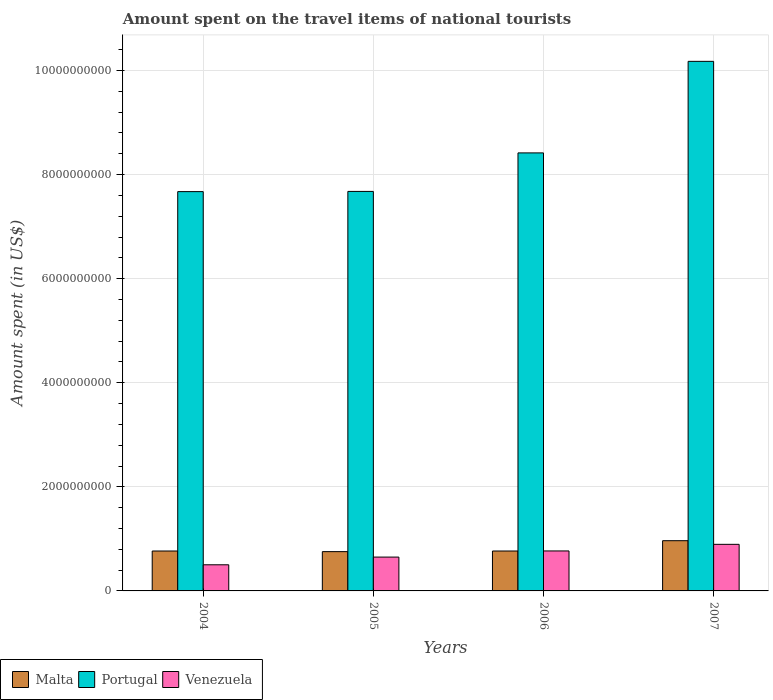How many different coloured bars are there?
Your answer should be very brief. 3. How many groups of bars are there?
Ensure brevity in your answer.  4. Are the number of bars on each tick of the X-axis equal?
Your response must be concise. Yes. How many bars are there on the 2nd tick from the left?
Ensure brevity in your answer.  3. How many bars are there on the 2nd tick from the right?
Make the answer very short. 3. What is the label of the 3rd group of bars from the left?
Ensure brevity in your answer.  2006. In how many cases, is the number of bars for a given year not equal to the number of legend labels?
Your response must be concise. 0. What is the amount spent on the travel items of national tourists in Malta in 2004?
Give a very brief answer. 7.67e+08. Across all years, what is the maximum amount spent on the travel items of national tourists in Venezuela?
Offer a terse response. 8.95e+08. Across all years, what is the minimum amount spent on the travel items of national tourists in Malta?
Provide a succinct answer. 7.55e+08. What is the total amount spent on the travel items of national tourists in Venezuela in the graph?
Your answer should be very brief. 2.82e+09. What is the difference between the amount spent on the travel items of national tourists in Portugal in 2005 and that in 2007?
Provide a short and direct response. -2.50e+09. What is the difference between the amount spent on the travel items of national tourists in Portugal in 2006 and the amount spent on the travel items of national tourists in Venezuela in 2004?
Offer a very short reply. 7.91e+09. What is the average amount spent on the travel items of national tourists in Malta per year?
Provide a succinct answer. 8.14e+08. In the year 2007, what is the difference between the amount spent on the travel items of national tourists in Portugal and amount spent on the travel items of national tourists in Malta?
Offer a terse response. 9.21e+09. In how many years, is the amount spent on the travel items of national tourists in Portugal greater than 7200000000 US$?
Offer a terse response. 4. What is the ratio of the amount spent on the travel items of national tourists in Malta in 2006 to that in 2007?
Offer a very short reply. 0.79. Is the amount spent on the travel items of national tourists in Malta in 2006 less than that in 2007?
Provide a short and direct response. Yes. What is the difference between the highest and the second highest amount spent on the travel items of national tourists in Venezuela?
Your response must be concise. 1.27e+08. What is the difference between the highest and the lowest amount spent on the travel items of national tourists in Portugal?
Provide a short and direct response. 2.50e+09. Is the sum of the amount spent on the travel items of national tourists in Portugal in 2004 and 2007 greater than the maximum amount spent on the travel items of national tourists in Venezuela across all years?
Ensure brevity in your answer.  Yes. What does the 1st bar from the left in 2004 represents?
Provide a short and direct response. Malta. How many years are there in the graph?
Give a very brief answer. 4. Does the graph contain grids?
Offer a terse response. Yes. Where does the legend appear in the graph?
Your answer should be very brief. Bottom left. How are the legend labels stacked?
Your answer should be compact. Horizontal. What is the title of the graph?
Provide a short and direct response. Amount spent on the travel items of national tourists. What is the label or title of the X-axis?
Offer a terse response. Years. What is the label or title of the Y-axis?
Ensure brevity in your answer.  Amount spent (in US$). What is the Amount spent (in US$) in Malta in 2004?
Provide a succinct answer. 7.67e+08. What is the Amount spent (in US$) in Portugal in 2004?
Offer a very short reply. 7.67e+09. What is the Amount spent (in US$) in Venezuela in 2004?
Provide a succinct answer. 5.02e+08. What is the Amount spent (in US$) in Malta in 2005?
Your answer should be very brief. 7.55e+08. What is the Amount spent (in US$) in Portugal in 2005?
Give a very brief answer. 7.68e+09. What is the Amount spent (in US$) in Venezuela in 2005?
Offer a very short reply. 6.50e+08. What is the Amount spent (in US$) in Malta in 2006?
Provide a succinct answer. 7.67e+08. What is the Amount spent (in US$) of Portugal in 2006?
Make the answer very short. 8.42e+09. What is the Amount spent (in US$) in Venezuela in 2006?
Your response must be concise. 7.68e+08. What is the Amount spent (in US$) in Malta in 2007?
Your answer should be compact. 9.65e+08. What is the Amount spent (in US$) in Portugal in 2007?
Your response must be concise. 1.02e+1. What is the Amount spent (in US$) in Venezuela in 2007?
Your response must be concise. 8.95e+08. Across all years, what is the maximum Amount spent (in US$) of Malta?
Provide a short and direct response. 9.65e+08. Across all years, what is the maximum Amount spent (in US$) of Portugal?
Make the answer very short. 1.02e+1. Across all years, what is the maximum Amount spent (in US$) of Venezuela?
Offer a very short reply. 8.95e+08. Across all years, what is the minimum Amount spent (in US$) of Malta?
Make the answer very short. 7.55e+08. Across all years, what is the minimum Amount spent (in US$) in Portugal?
Ensure brevity in your answer.  7.67e+09. Across all years, what is the minimum Amount spent (in US$) in Venezuela?
Keep it short and to the point. 5.02e+08. What is the total Amount spent (in US$) in Malta in the graph?
Your response must be concise. 3.25e+09. What is the total Amount spent (in US$) in Portugal in the graph?
Ensure brevity in your answer.  3.39e+1. What is the total Amount spent (in US$) of Venezuela in the graph?
Provide a succinct answer. 2.82e+09. What is the difference between the Amount spent (in US$) in Portugal in 2004 and that in 2005?
Your answer should be very brief. -4.00e+06. What is the difference between the Amount spent (in US$) in Venezuela in 2004 and that in 2005?
Your response must be concise. -1.48e+08. What is the difference between the Amount spent (in US$) of Malta in 2004 and that in 2006?
Your answer should be compact. 0. What is the difference between the Amount spent (in US$) of Portugal in 2004 and that in 2006?
Keep it short and to the point. -7.44e+08. What is the difference between the Amount spent (in US$) in Venezuela in 2004 and that in 2006?
Provide a short and direct response. -2.66e+08. What is the difference between the Amount spent (in US$) in Malta in 2004 and that in 2007?
Your answer should be compact. -1.98e+08. What is the difference between the Amount spent (in US$) in Portugal in 2004 and that in 2007?
Give a very brief answer. -2.50e+09. What is the difference between the Amount spent (in US$) in Venezuela in 2004 and that in 2007?
Ensure brevity in your answer.  -3.93e+08. What is the difference between the Amount spent (in US$) in Malta in 2005 and that in 2006?
Offer a very short reply. -1.20e+07. What is the difference between the Amount spent (in US$) of Portugal in 2005 and that in 2006?
Provide a succinct answer. -7.40e+08. What is the difference between the Amount spent (in US$) in Venezuela in 2005 and that in 2006?
Offer a terse response. -1.18e+08. What is the difference between the Amount spent (in US$) of Malta in 2005 and that in 2007?
Make the answer very short. -2.10e+08. What is the difference between the Amount spent (in US$) of Portugal in 2005 and that in 2007?
Provide a succinct answer. -2.50e+09. What is the difference between the Amount spent (in US$) of Venezuela in 2005 and that in 2007?
Make the answer very short. -2.45e+08. What is the difference between the Amount spent (in US$) in Malta in 2006 and that in 2007?
Provide a short and direct response. -1.98e+08. What is the difference between the Amount spent (in US$) of Portugal in 2006 and that in 2007?
Keep it short and to the point. -1.76e+09. What is the difference between the Amount spent (in US$) in Venezuela in 2006 and that in 2007?
Your answer should be very brief. -1.27e+08. What is the difference between the Amount spent (in US$) in Malta in 2004 and the Amount spent (in US$) in Portugal in 2005?
Your answer should be compact. -6.91e+09. What is the difference between the Amount spent (in US$) of Malta in 2004 and the Amount spent (in US$) of Venezuela in 2005?
Provide a succinct answer. 1.17e+08. What is the difference between the Amount spent (in US$) of Portugal in 2004 and the Amount spent (in US$) of Venezuela in 2005?
Ensure brevity in your answer.  7.02e+09. What is the difference between the Amount spent (in US$) in Malta in 2004 and the Amount spent (in US$) in Portugal in 2006?
Ensure brevity in your answer.  -7.65e+09. What is the difference between the Amount spent (in US$) of Malta in 2004 and the Amount spent (in US$) of Venezuela in 2006?
Your response must be concise. -1.00e+06. What is the difference between the Amount spent (in US$) in Portugal in 2004 and the Amount spent (in US$) in Venezuela in 2006?
Your answer should be compact. 6.90e+09. What is the difference between the Amount spent (in US$) in Malta in 2004 and the Amount spent (in US$) in Portugal in 2007?
Your answer should be very brief. -9.41e+09. What is the difference between the Amount spent (in US$) of Malta in 2004 and the Amount spent (in US$) of Venezuela in 2007?
Your answer should be compact. -1.28e+08. What is the difference between the Amount spent (in US$) in Portugal in 2004 and the Amount spent (in US$) in Venezuela in 2007?
Provide a short and direct response. 6.78e+09. What is the difference between the Amount spent (in US$) in Malta in 2005 and the Amount spent (in US$) in Portugal in 2006?
Keep it short and to the point. -7.66e+09. What is the difference between the Amount spent (in US$) in Malta in 2005 and the Amount spent (in US$) in Venezuela in 2006?
Make the answer very short. -1.30e+07. What is the difference between the Amount spent (in US$) of Portugal in 2005 and the Amount spent (in US$) of Venezuela in 2006?
Offer a very short reply. 6.91e+09. What is the difference between the Amount spent (in US$) in Malta in 2005 and the Amount spent (in US$) in Portugal in 2007?
Provide a short and direct response. -9.42e+09. What is the difference between the Amount spent (in US$) in Malta in 2005 and the Amount spent (in US$) in Venezuela in 2007?
Offer a terse response. -1.40e+08. What is the difference between the Amount spent (in US$) of Portugal in 2005 and the Amount spent (in US$) of Venezuela in 2007?
Offer a very short reply. 6.78e+09. What is the difference between the Amount spent (in US$) of Malta in 2006 and the Amount spent (in US$) of Portugal in 2007?
Provide a short and direct response. -9.41e+09. What is the difference between the Amount spent (in US$) of Malta in 2006 and the Amount spent (in US$) of Venezuela in 2007?
Make the answer very short. -1.28e+08. What is the difference between the Amount spent (in US$) of Portugal in 2006 and the Amount spent (in US$) of Venezuela in 2007?
Your answer should be compact. 7.52e+09. What is the average Amount spent (in US$) of Malta per year?
Offer a very short reply. 8.14e+08. What is the average Amount spent (in US$) in Portugal per year?
Give a very brief answer. 8.48e+09. What is the average Amount spent (in US$) of Venezuela per year?
Provide a succinct answer. 7.04e+08. In the year 2004, what is the difference between the Amount spent (in US$) in Malta and Amount spent (in US$) in Portugal?
Your answer should be very brief. -6.90e+09. In the year 2004, what is the difference between the Amount spent (in US$) in Malta and Amount spent (in US$) in Venezuela?
Provide a short and direct response. 2.65e+08. In the year 2004, what is the difference between the Amount spent (in US$) in Portugal and Amount spent (in US$) in Venezuela?
Offer a very short reply. 7.17e+09. In the year 2005, what is the difference between the Amount spent (in US$) in Malta and Amount spent (in US$) in Portugal?
Your answer should be compact. -6.92e+09. In the year 2005, what is the difference between the Amount spent (in US$) of Malta and Amount spent (in US$) of Venezuela?
Offer a terse response. 1.05e+08. In the year 2005, what is the difference between the Amount spent (in US$) in Portugal and Amount spent (in US$) in Venezuela?
Give a very brief answer. 7.03e+09. In the year 2006, what is the difference between the Amount spent (in US$) in Malta and Amount spent (in US$) in Portugal?
Your response must be concise. -7.65e+09. In the year 2006, what is the difference between the Amount spent (in US$) of Portugal and Amount spent (in US$) of Venezuela?
Keep it short and to the point. 7.65e+09. In the year 2007, what is the difference between the Amount spent (in US$) of Malta and Amount spent (in US$) of Portugal?
Ensure brevity in your answer.  -9.21e+09. In the year 2007, what is the difference between the Amount spent (in US$) in Malta and Amount spent (in US$) in Venezuela?
Offer a terse response. 7.00e+07. In the year 2007, what is the difference between the Amount spent (in US$) in Portugal and Amount spent (in US$) in Venezuela?
Keep it short and to the point. 9.28e+09. What is the ratio of the Amount spent (in US$) in Malta in 2004 to that in 2005?
Keep it short and to the point. 1.02. What is the ratio of the Amount spent (in US$) of Portugal in 2004 to that in 2005?
Your response must be concise. 1. What is the ratio of the Amount spent (in US$) of Venezuela in 2004 to that in 2005?
Your answer should be compact. 0.77. What is the ratio of the Amount spent (in US$) of Malta in 2004 to that in 2006?
Your response must be concise. 1. What is the ratio of the Amount spent (in US$) in Portugal in 2004 to that in 2006?
Provide a succinct answer. 0.91. What is the ratio of the Amount spent (in US$) in Venezuela in 2004 to that in 2006?
Offer a very short reply. 0.65. What is the ratio of the Amount spent (in US$) of Malta in 2004 to that in 2007?
Your answer should be compact. 0.79. What is the ratio of the Amount spent (in US$) of Portugal in 2004 to that in 2007?
Your answer should be compact. 0.75. What is the ratio of the Amount spent (in US$) in Venezuela in 2004 to that in 2007?
Keep it short and to the point. 0.56. What is the ratio of the Amount spent (in US$) in Malta in 2005 to that in 2006?
Make the answer very short. 0.98. What is the ratio of the Amount spent (in US$) in Portugal in 2005 to that in 2006?
Make the answer very short. 0.91. What is the ratio of the Amount spent (in US$) in Venezuela in 2005 to that in 2006?
Your answer should be compact. 0.85. What is the ratio of the Amount spent (in US$) in Malta in 2005 to that in 2007?
Your answer should be compact. 0.78. What is the ratio of the Amount spent (in US$) of Portugal in 2005 to that in 2007?
Your answer should be compact. 0.75. What is the ratio of the Amount spent (in US$) of Venezuela in 2005 to that in 2007?
Your answer should be very brief. 0.73. What is the ratio of the Amount spent (in US$) in Malta in 2006 to that in 2007?
Provide a short and direct response. 0.79. What is the ratio of the Amount spent (in US$) in Portugal in 2006 to that in 2007?
Provide a succinct answer. 0.83. What is the ratio of the Amount spent (in US$) of Venezuela in 2006 to that in 2007?
Provide a succinct answer. 0.86. What is the difference between the highest and the second highest Amount spent (in US$) of Malta?
Make the answer very short. 1.98e+08. What is the difference between the highest and the second highest Amount spent (in US$) of Portugal?
Make the answer very short. 1.76e+09. What is the difference between the highest and the second highest Amount spent (in US$) of Venezuela?
Offer a terse response. 1.27e+08. What is the difference between the highest and the lowest Amount spent (in US$) in Malta?
Keep it short and to the point. 2.10e+08. What is the difference between the highest and the lowest Amount spent (in US$) in Portugal?
Ensure brevity in your answer.  2.50e+09. What is the difference between the highest and the lowest Amount spent (in US$) of Venezuela?
Provide a short and direct response. 3.93e+08. 